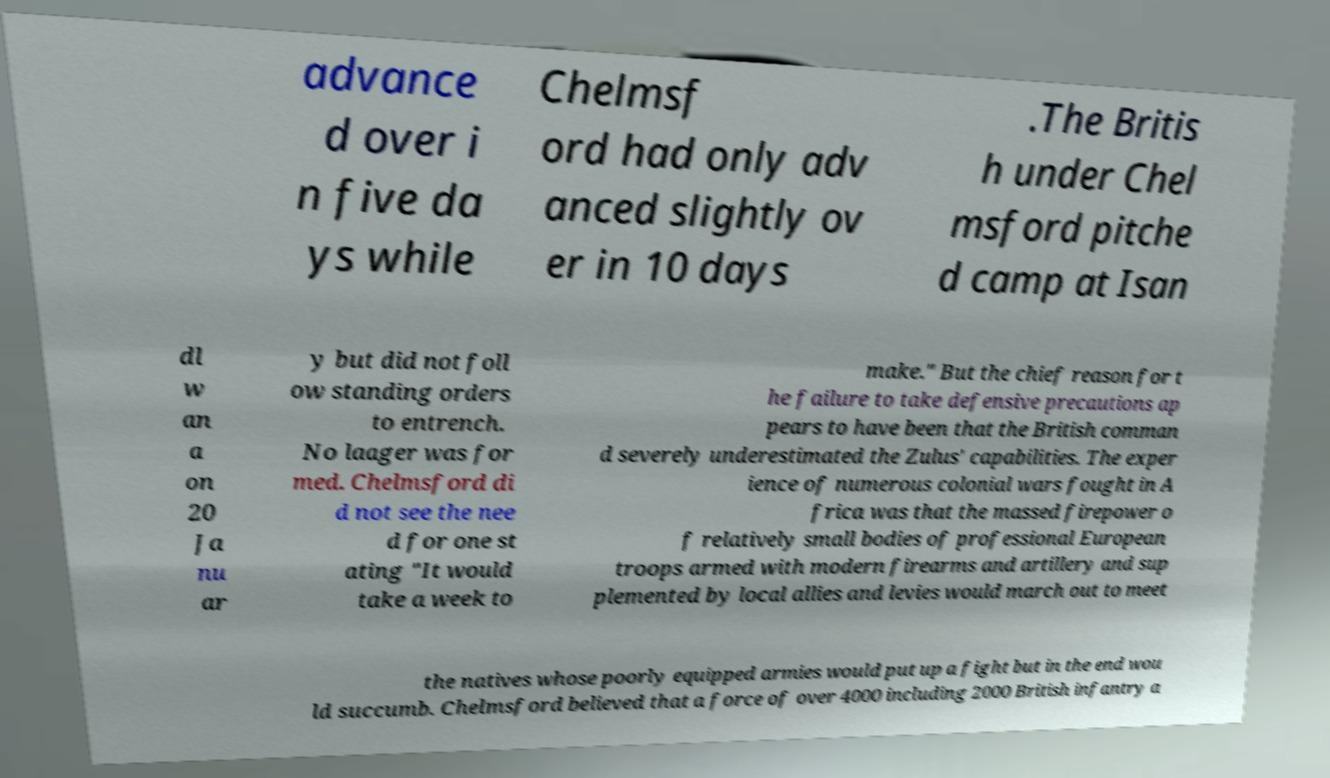Could you assist in decoding the text presented in this image and type it out clearly? advance d over i n five da ys while Chelmsf ord had only adv anced slightly ov er in 10 days .The Britis h under Chel msford pitche d camp at Isan dl w an a on 20 Ja nu ar y but did not foll ow standing orders to entrench. No laager was for med. Chelmsford di d not see the nee d for one st ating "It would take a week to make." But the chief reason for t he failure to take defensive precautions ap pears to have been that the British comman d severely underestimated the Zulus' capabilities. The exper ience of numerous colonial wars fought in A frica was that the massed firepower o f relatively small bodies of professional European troops armed with modern firearms and artillery and sup plemented by local allies and levies would march out to meet the natives whose poorly equipped armies would put up a fight but in the end wou ld succumb. Chelmsford believed that a force of over 4000 including 2000 British infantry a 